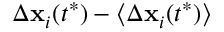<formula> <loc_0><loc_0><loc_500><loc_500>\Delta x _ { i } ( t ^ { * } ) - \langle \Delta x _ { i } ( t ^ { * } ) \rangle</formula> 